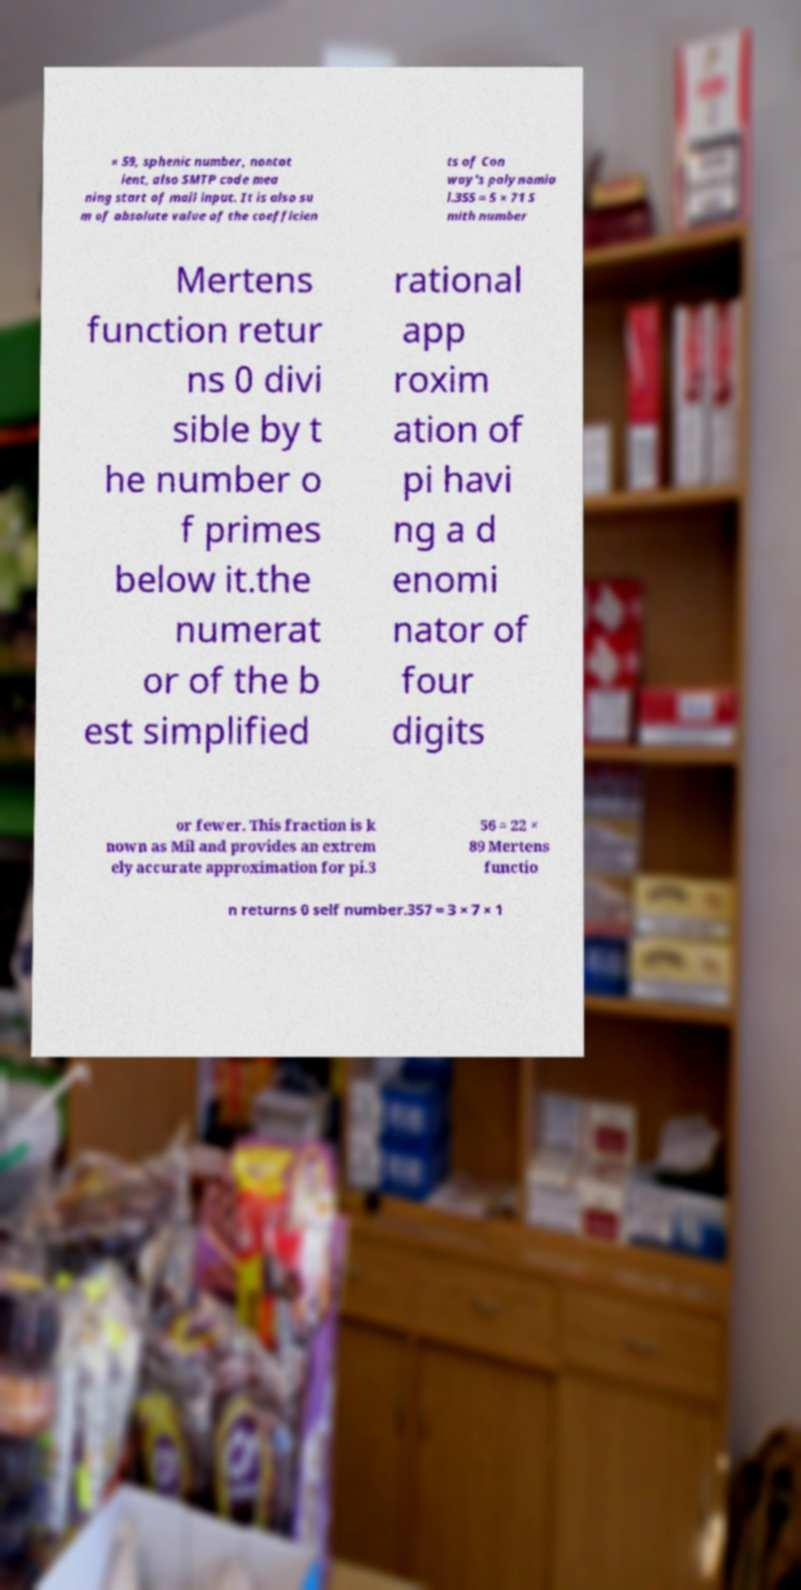What messages or text are displayed in this image? I need them in a readable, typed format. × 59, sphenic number, nontot ient, also SMTP code mea ning start of mail input. It is also su m of absolute value of the coefficien ts of Con way's polynomia l.355 = 5 × 71 S mith number Mertens function retur ns 0 divi sible by t he number o f primes below it.the numerat or of the b est simplified rational app roxim ation of pi havi ng a d enomi nator of four digits or fewer. This fraction is k nown as Mil and provides an extrem ely accurate approximation for pi.3 56 = 22 × 89 Mertens functio n returns 0 self number.357 = 3 × 7 × 1 